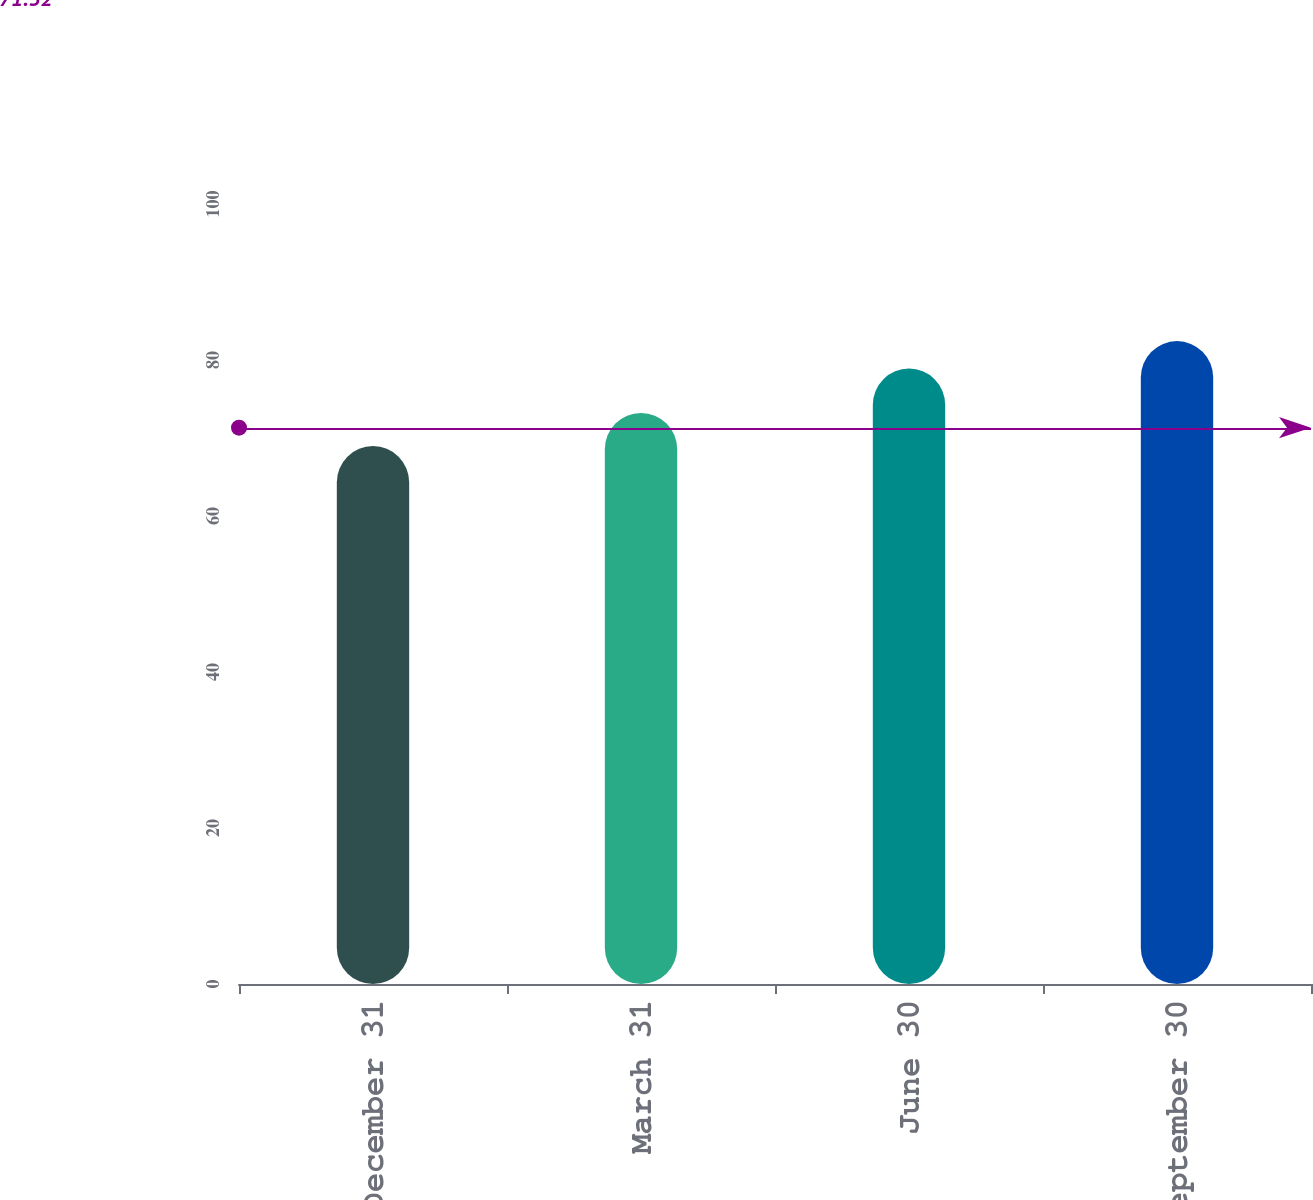Convert chart to OTSL. <chart><loc_0><loc_0><loc_500><loc_500><bar_chart><fcel>December 31<fcel>March 31<fcel>June 30<fcel>September 30<nl><fcel>68.96<fcel>73.21<fcel>78.9<fcel>82.42<nl></chart> 